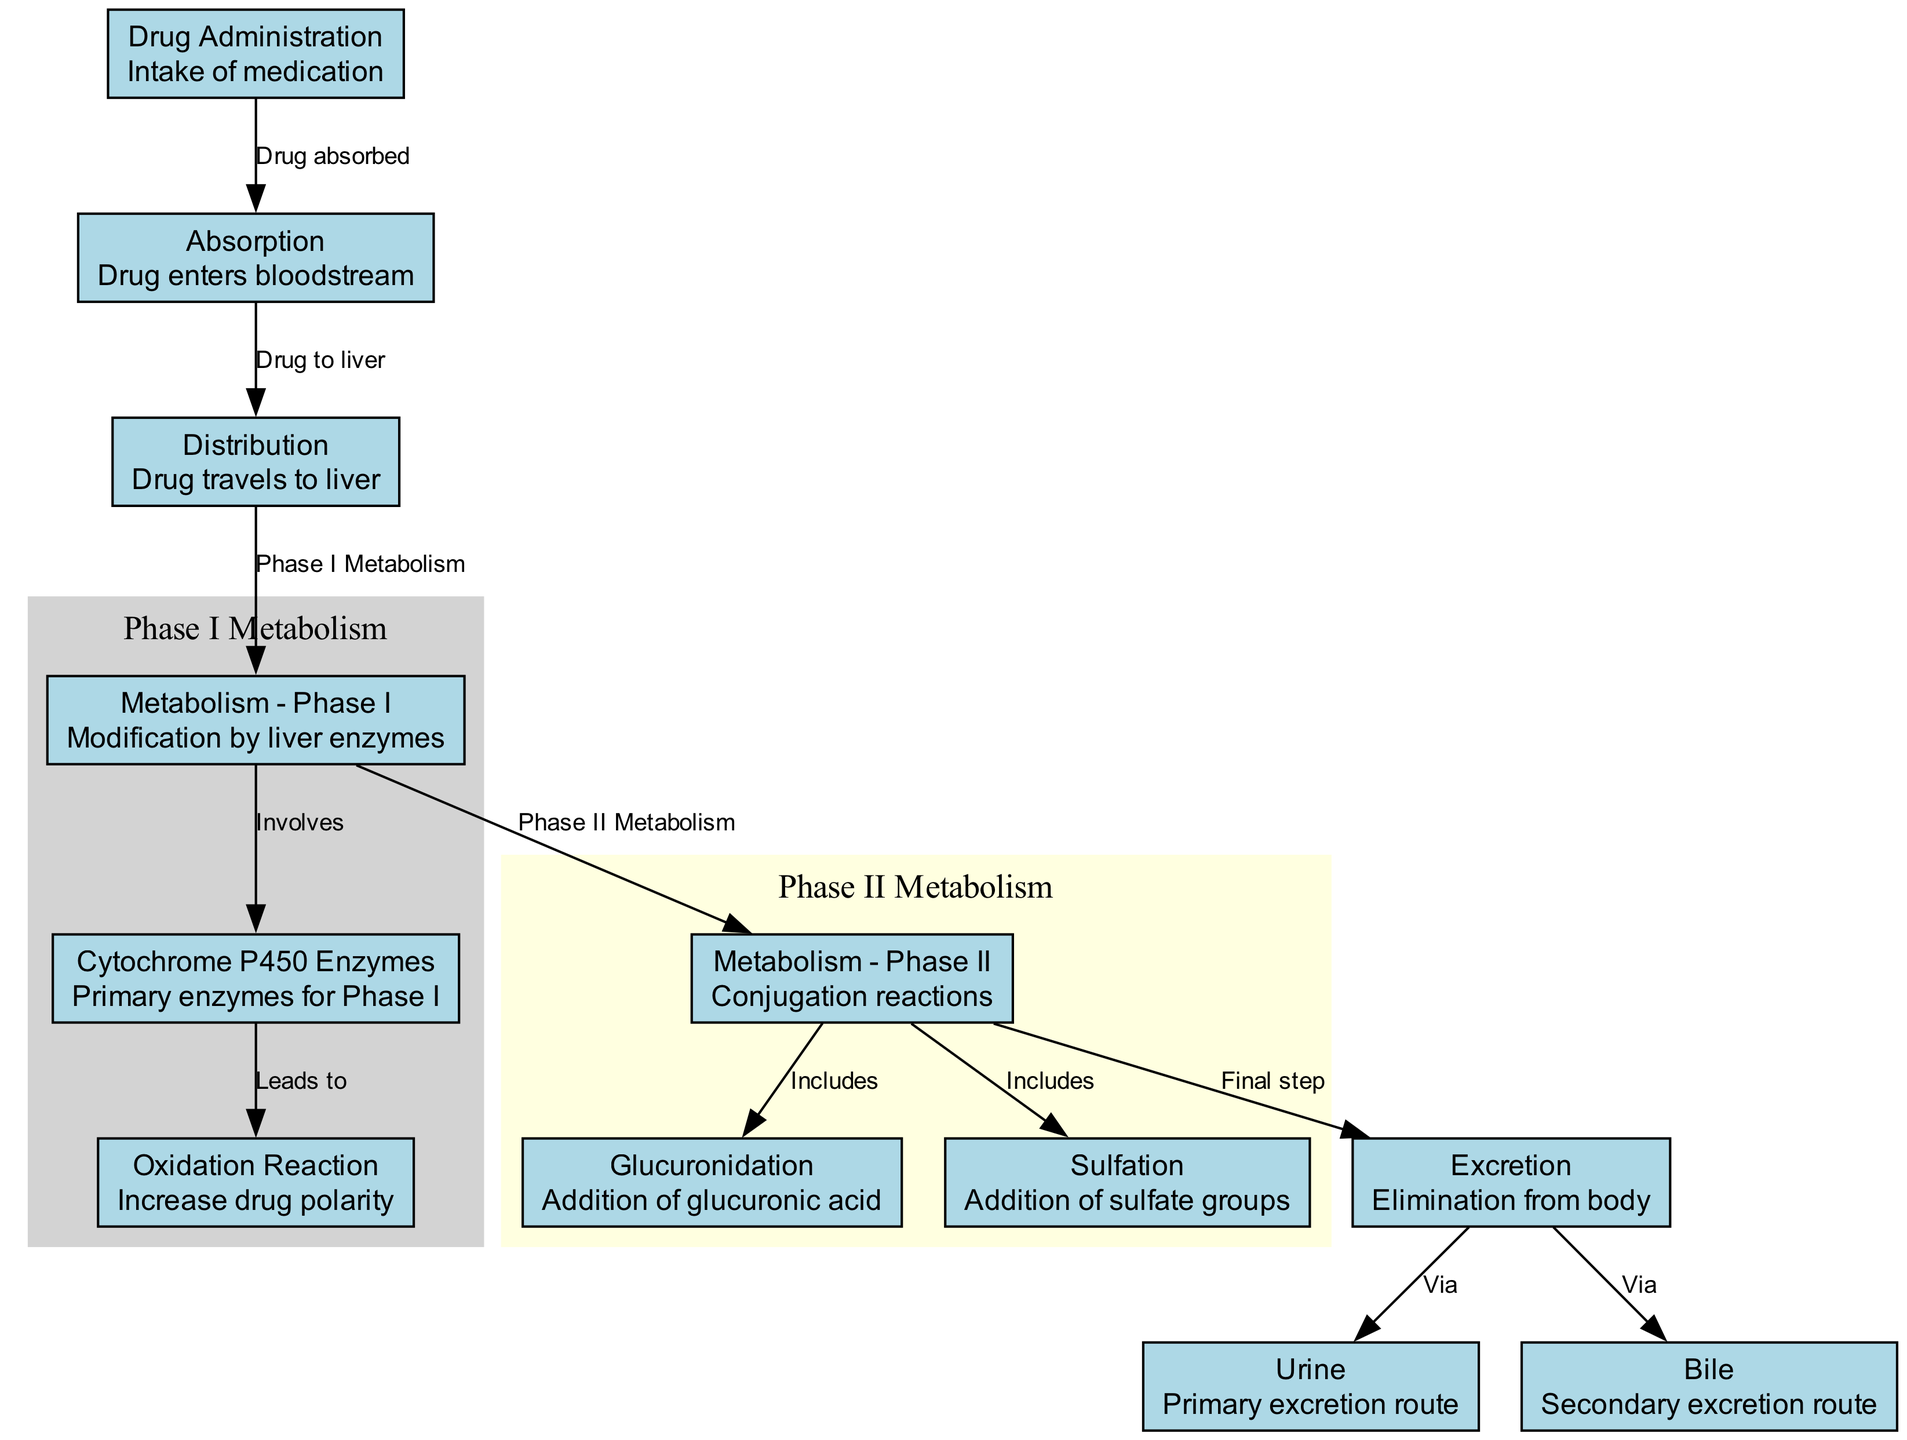What is the first step in the drug metabolism pathway? The diagram shows that "Drug Administration" is the first step, representing the intake of medication.
Answer: Drug Administration How many nodes are in the diagram? By counting the nodes listed in the diagram data, there are 12 nodes representing different steps and components of drug metabolism.
Answer: 12 What is the relationship between "Phase I Metabolism" and "Cytochrome P450 Enzymes"? The diagram indicates that "Phase I Metabolism" involves the "Cytochrome P450 Enzymes," showing that these enzymes are critical to this phase of metabolism.
Answer: Involves Which route is primarily used for excretion? From the diagram, "Urine" is indicated as the primary route for the elimination of the drug from the body.
Answer: Urine What step follows "Phase II Metabolism"? As per the diagram, the step that follows "Phase II Metabolism" is "Excretion," indicating that after this phase, the drug is eliminated from the body.
Answer: Excretion What kind of reactions occur during "Metabolism - Phase II"? The diagram specifies that "Metabolism - Phase II" includes "Glucuronidation" and "Sulfation," which are forms of conjugation reactions.
Answer: Conjugation reactions How does drug absorption occur according to the diagram? The flow shows that drug absorption leads to "Drug to liver," emphasizing that the drug is transferred to the liver after entering the bloodstream.
Answer: Drug to liver What modification process happens during "Metabolism - Phase I"? The diagram indicates that during "Metabolism - Phase I," there is a modification by liver enzymes, specifically through oxidation reactions that increase drug polarity.
Answer: Modification by liver enzymes What secondary route is specified for drug excretion? According to the diagram, the secondary route for drug excretion is referred to as "Bile."
Answer: Bile 